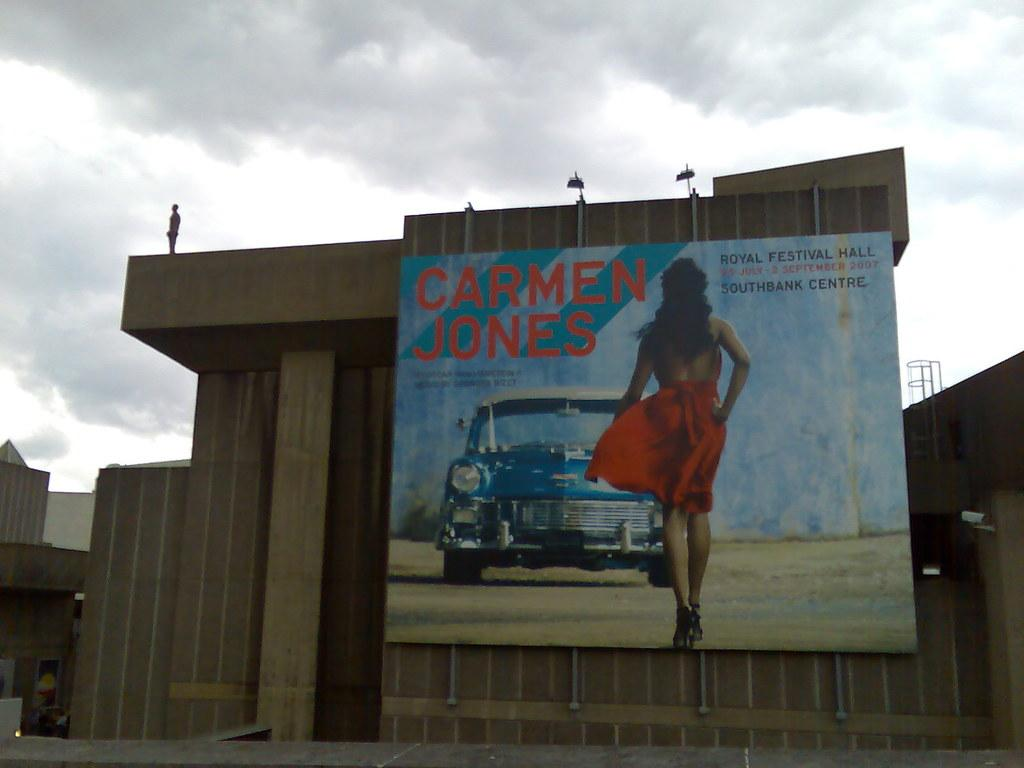<image>
Describe the image concisely. An advertisement of Carmen Jones walking towards a classic blue car. 